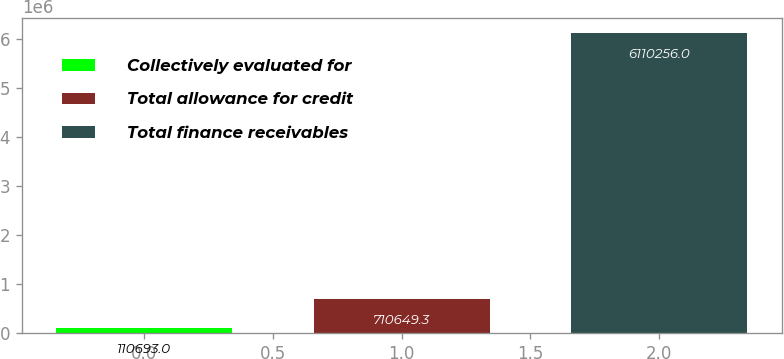<chart> <loc_0><loc_0><loc_500><loc_500><bar_chart><fcel>Collectively evaluated for<fcel>Total allowance for credit<fcel>Total finance receivables<nl><fcel>110693<fcel>710649<fcel>6.11026e+06<nl></chart> 